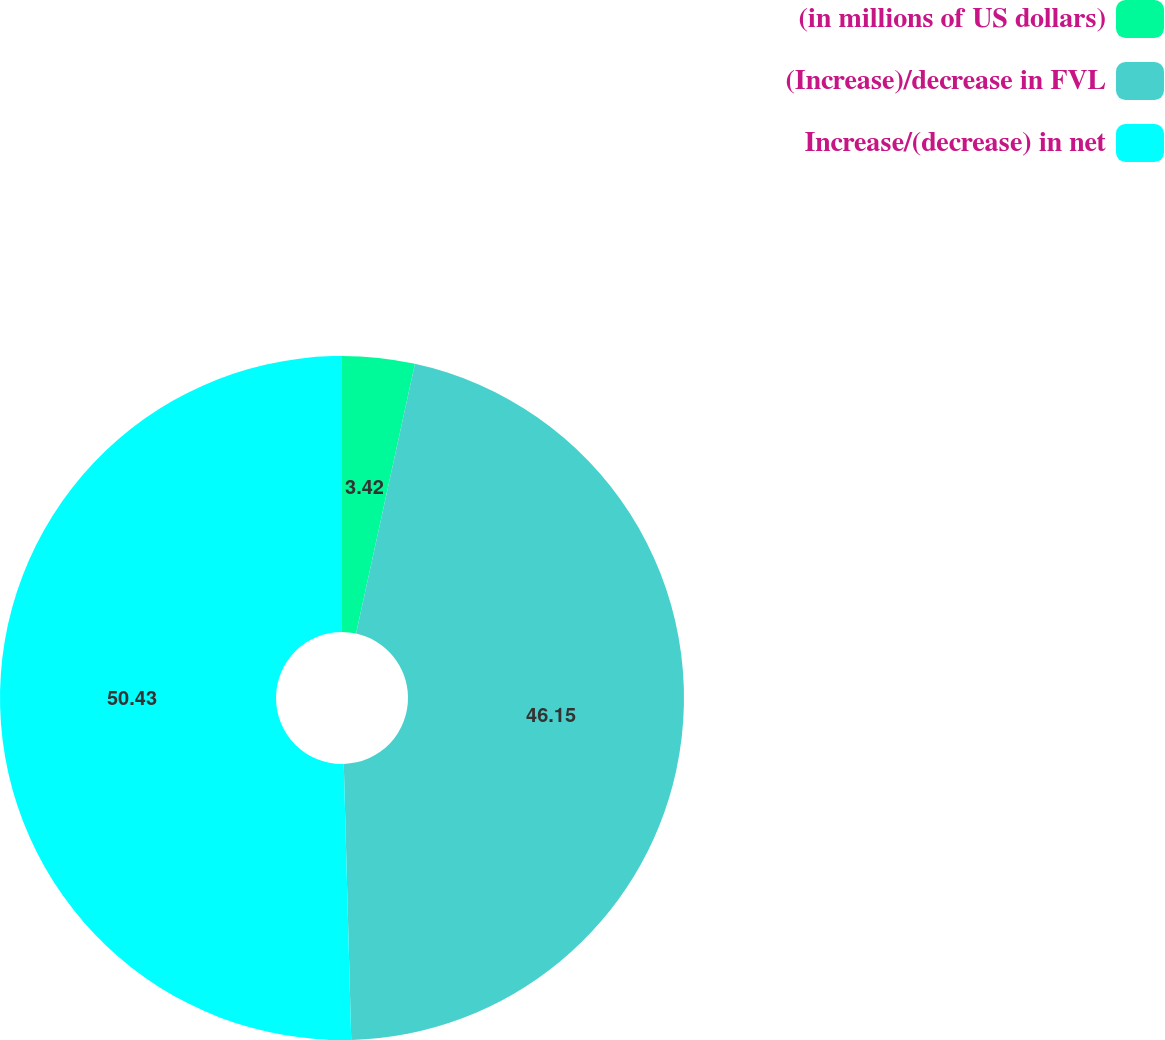Convert chart. <chart><loc_0><loc_0><loc_500><loc_500><pie_chart><fcel>(in millions of US dollars)<fcel>(Increase)/decrease in FVL<fcel>Increase/(decrease) in net<nl><fcel>3.42%<fcel>46.15%<fcel>50.43%<nl></chart> 